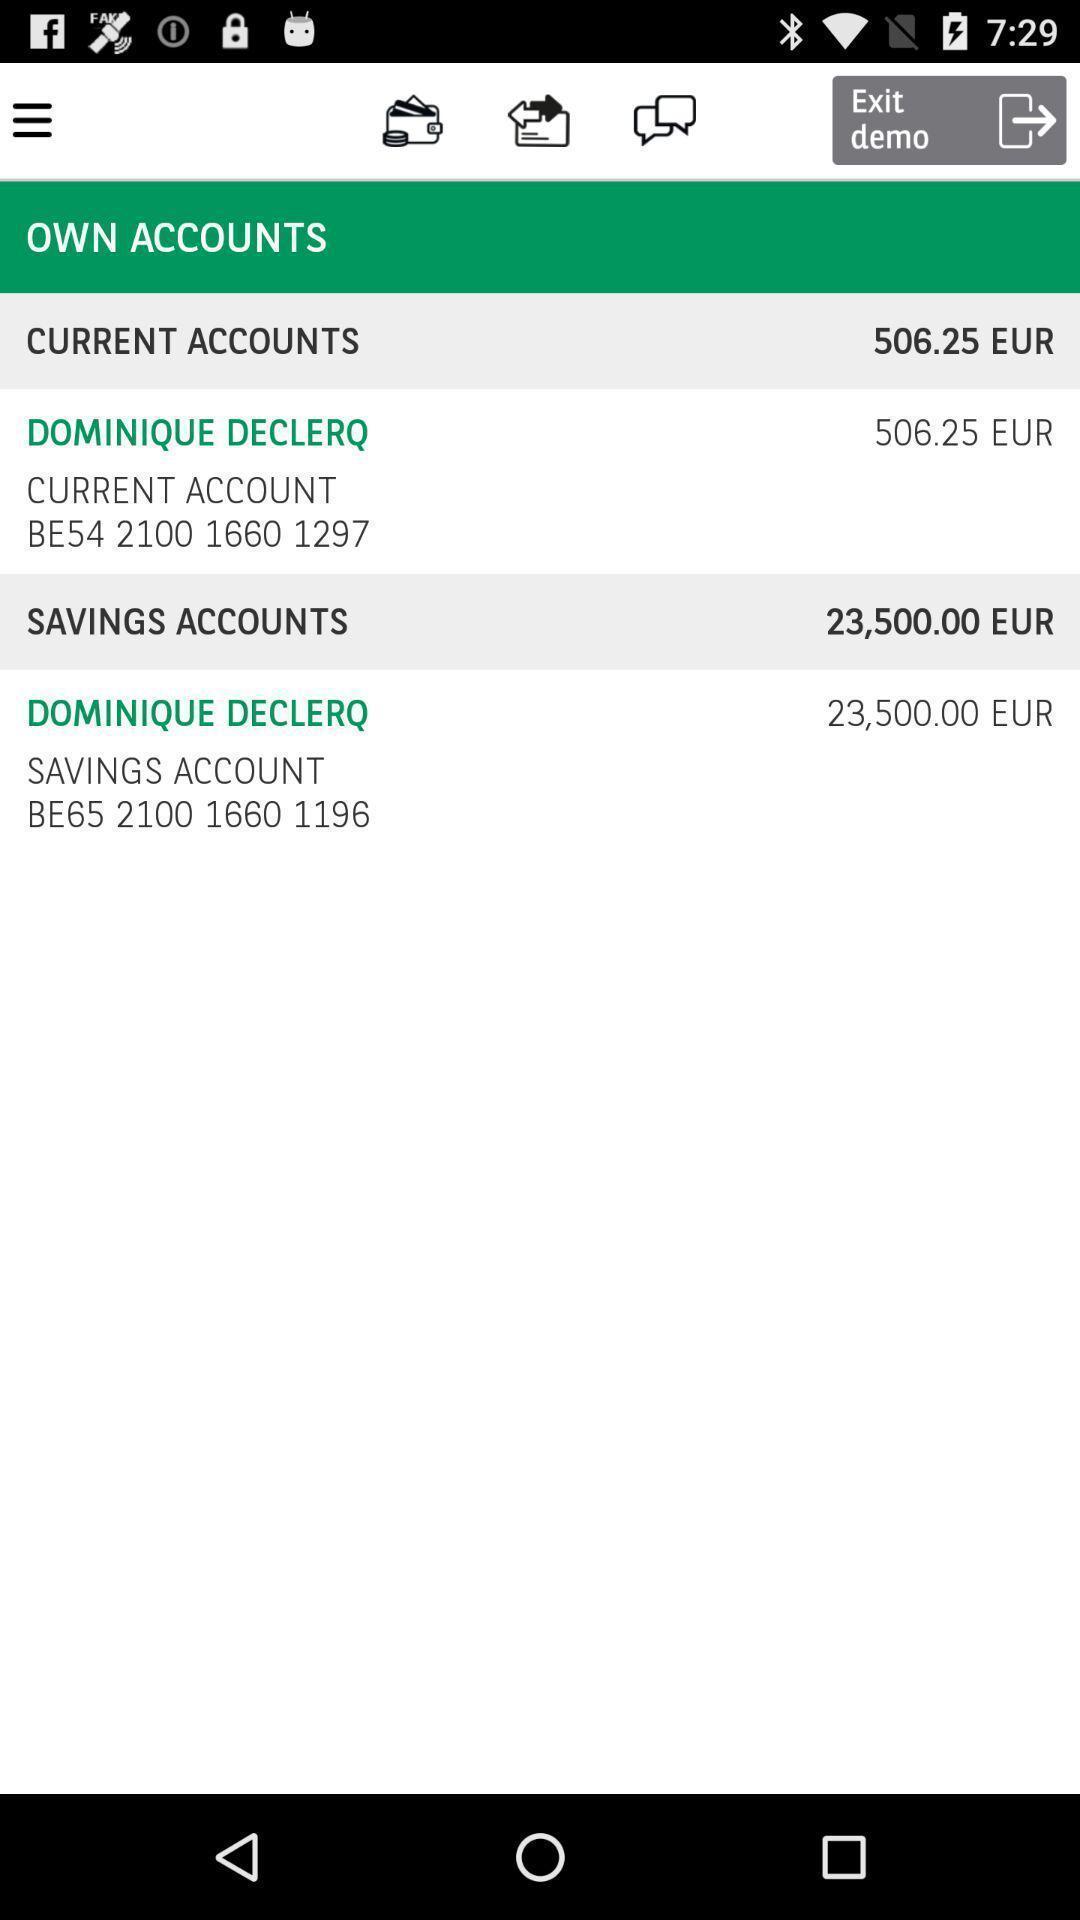Provide a detailed account of this screenshot. Page displaying options of accounts. Please provide a description for this image. Various account details displayed in a financial services app. 